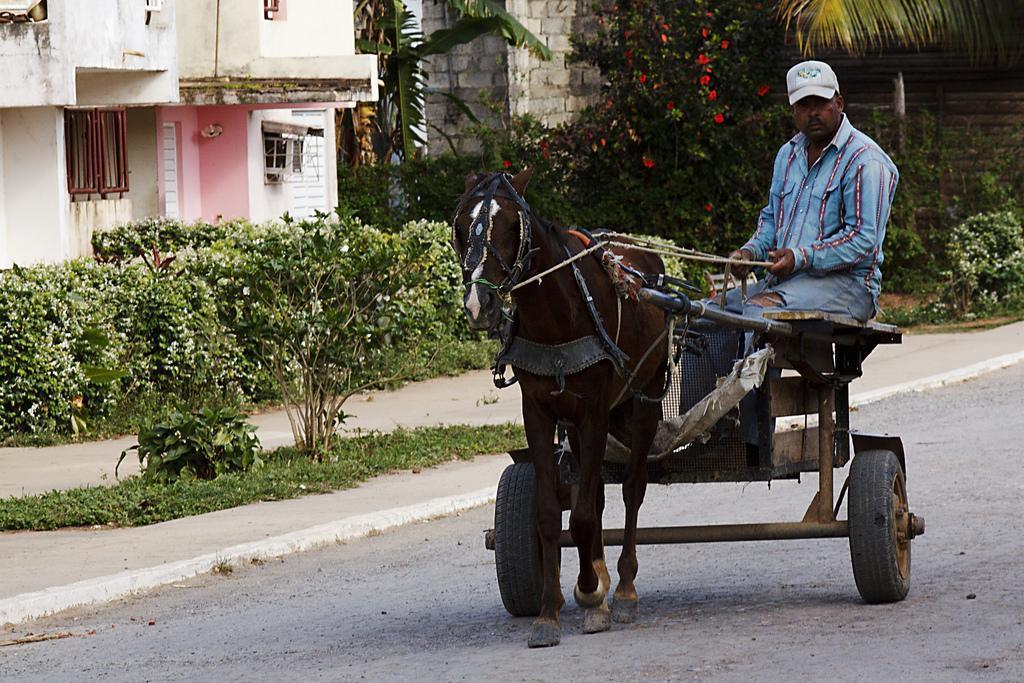How many wheels are on the pony cart?
Give a very brief answer. 2. How many wheels on the wagon?
Give a very brief answer. 2. How many horses are in the photo?
Give a very brief answer. 1. How many wheels does the carriage have?
Give a very brief answer. 2. How many legs does the horse have?
Give a very brief answer. 4. How many people are shown?
Give a very brief answer. 1. How many animals are shown?
Give a very brief answer. 1. 